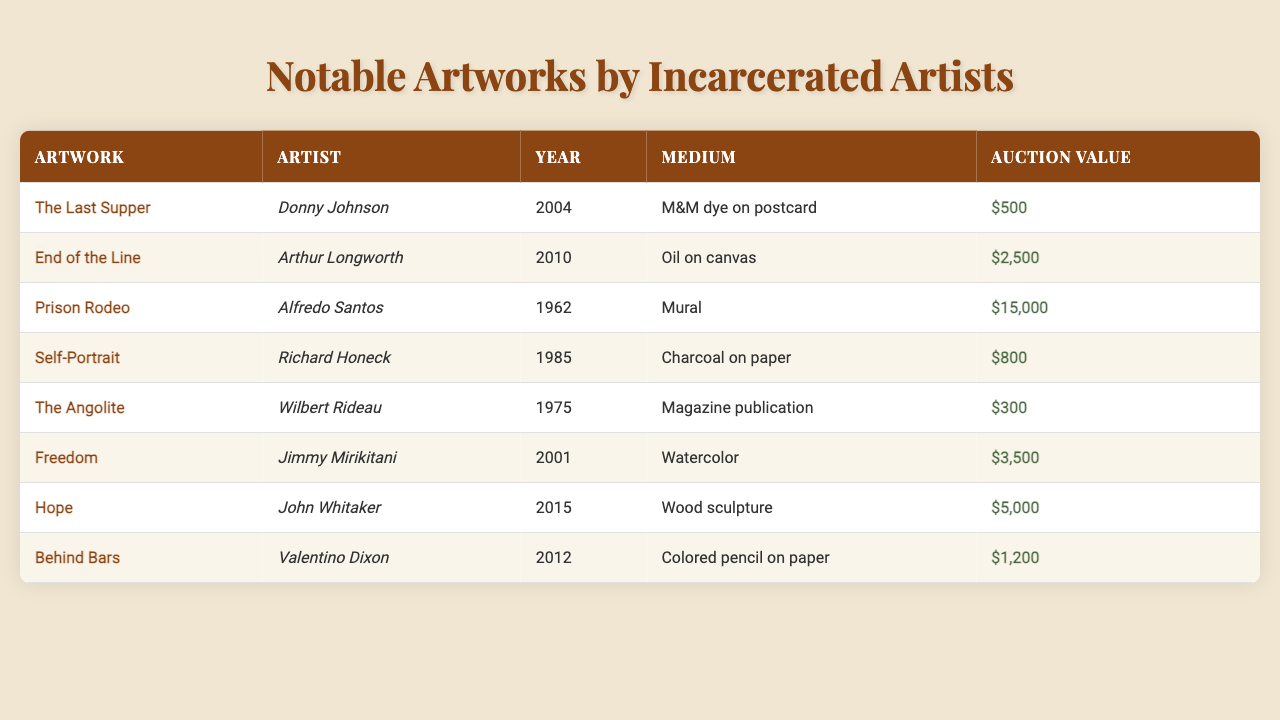What is the auction value of "Prison Rodeo"? The auction value for "Prison Rodeo" is provided directly in the table, listed next to the artwork title. It is 15,000.
Answer: 15000 Who is the artist of the artwork titled "Freedom"? The table shows that "Freedom" was created by Jimmy Mirikitani, as indicated in the corresponding row under the "Artist" column.
Answer: Jimmy Mirikitani What year was "Self-Portrait" created? The "Year" column shows that "Self-Portrait" was created in 1985, which is directly listed in the respective row.
Answer: 1985 Which artwork has the lowest auction value? By examining the auction values in the table, "The Angolite" has the lowest auction value at 300, while all other artworks have higher values.
Answer: The Angolite What is the medium used in "End of the Line"? Looking at the table, the medium for "End of the Line" is listed as "Oil on canvas," which provides a clear answer.
Answer: Oil on canvas What is the average auction value of the artworks listed? First, we sum the auction values: 500 + 2500 + 15000 + 800 + 300 + 3500 + 5000 + 1200 = 25,800. Next, we divide this by the number of artworks, which is 8, yielding 25,800 / 8 = 3225.
Answer: 3225 Is there any artwork created in the year 2012? By scanning the "Year" column, we notice "Behind Bars" was created in 2012. Thus, there is at least one artwork from that year.
Answer: Yes How many artworks have an auction value greater than 5000? The auction values greater than 5000 are: 15000 (Prison Rodeo), 3500 (Freedom), and 5000 (Hope); adding them gives us 3 artworks that meet this condition.
Answer: 3 What is the total auction value of artworks created between 2000 and 2015? We identify the artworks created between those years: "Freedom" (3500), "Hope" (5000), and "Behind Bars" (1200). Summing their auction values: 3500 + 5000 + 1200 = 9700.
Answer: 9700 Which artist created the artwork with the highest auction value? The table reveals that "Prison Rodeo" by Alfredo Santos has the highest auction value at 15000, making him the artist associated with the highest valued artwork.
Answer: Alfredo Santos What is the difference in auction value between the most expensive artwork and the least expensive artwork? The most expensive artwork is "Prison Rodeo" at 15000, while the least expensive is "The Angolite" at 300. The difference is 15000 - 300 = 14700.
Answer: 14700 